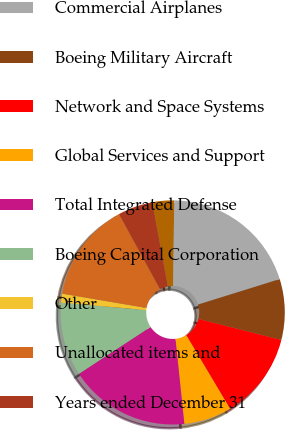<chart> <loc_0><loc_0><loc_500><loc_500><pie_chart><fcel>As of December 31<fcel>Commercial Airplanes<fcel>Boeing Military Aircraft<fcel>Network and Space Systems<fcel>Global Services and Support<fcel>Total Integrated Defense<fcel>Boeing Capital Corporation<fcel>Other<fcel>Unallocated items and<fcel>Years ended December 31<nl><fcel>3.15%<fcel>19.98%<fcel>8.76%<fcel>12.5%<fcel>6.89%<fcel>17.43%<fcel>10.63%<fcel>1.28%<fcel>14.37%<fcel>5.02%<nl></chart> 